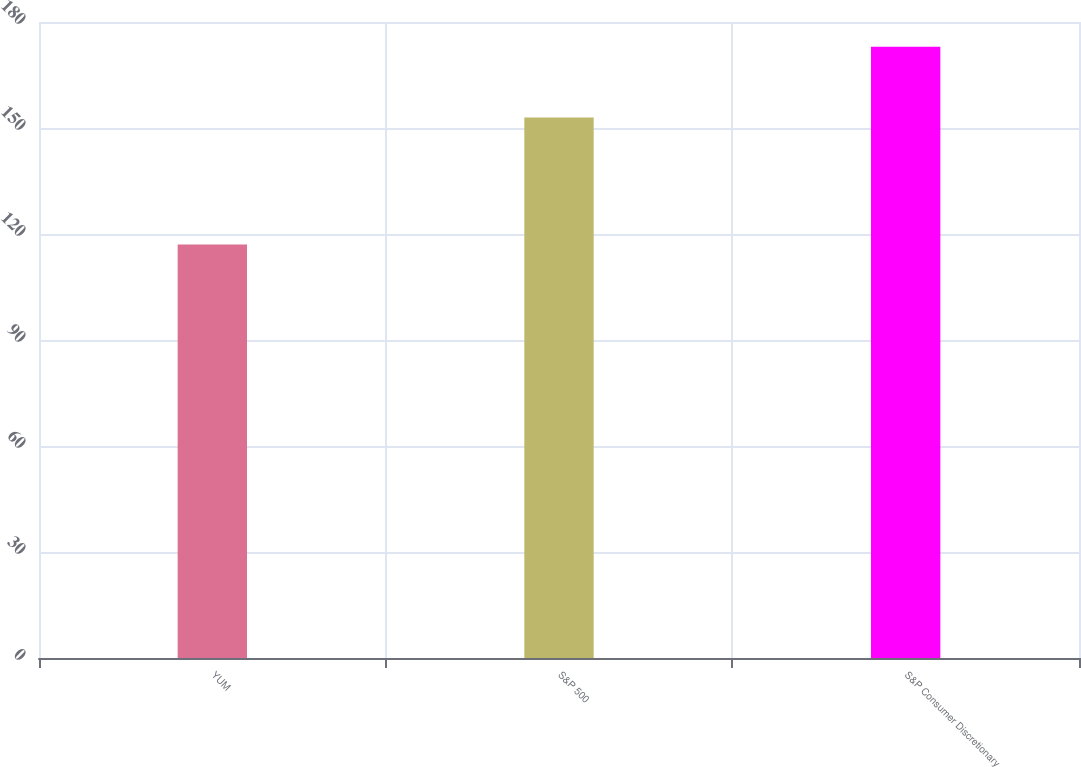<chart> <loc_0><loc_0><loc_500><loc_500><bar_chart><fcel>YUM<fcel>S&P 500<fcel>S&P Consumer Discretionary<nl><fcel>117<fcel>153<fcel>173<nl></chart> 